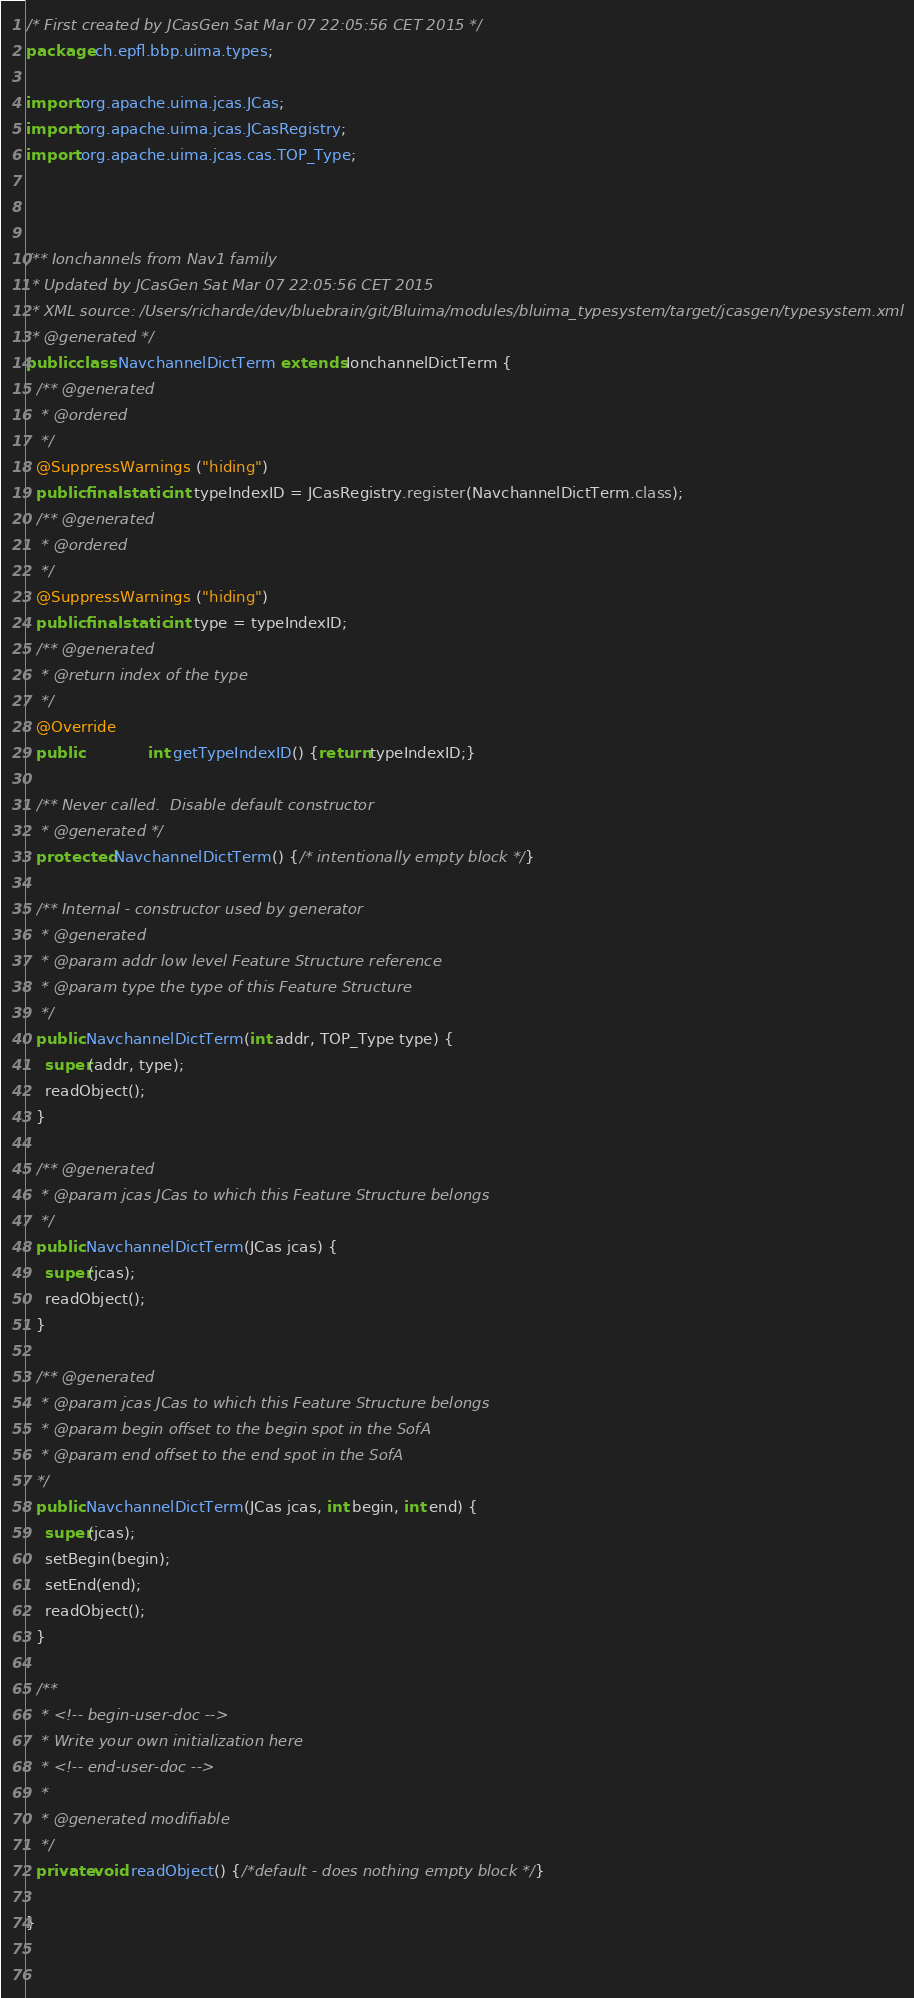<code> <loc_0><loc_0><loc_500><loc_500><_Java_>

/* First created by JCasGen Sat Mar 07 22:05:56 CET 2015 */
package ch.epfl.bbp.uima.types;

import org.apache.uima.jcas.JCas; 
import org.apache.uima.jcas.JCasRegistry;
import org.apache.uima.jcas.cas.TOP_Type;



/** Ionchannels from Nav1 family
 * Updated by JCasGen Sat Mar 07 22:05:56 CET 2015
 * XML source: /Users/richarde/dev/bluebrain/git/Bluima/modules/bluima_typesystem/target/jcasgen/typesystem.xml
 * @generated */
public class NavchannelDictTerm extends IonchannelDictTerm {
  /** @generated
   * @ordered 
   */
  @SuppressWarnings ("hiding")
  public final static int typeIndexID = JCasRegistry.register(NavchannelDictTerm.class);
  /** @generated
   * @ordered 
   */
  @SuppressWarnings ("hiding")
  public final static int type = typeIndexID;
  /** @generated
   * @return index of the type  
   */
  @Override
  public              int getTypeIndexID() {return typeIndexID;}
 
  /** Never called.  Disable default constructor
   * @generated */
  protected NavchannelDictTerm() {/* intentionally empty block */}
    
  /** Internal - constructor used by generator 
   * @generated
   * @param addr low level Feature Structure reference
   * @param type the type of this Feature Structure 
   */
  public NavchannelDictTerm(int addr, TOP_Type type) {
    super(addr, type);
    readObject();
  }
  
  /** @generated
   * @param jcas JCas to which this Feature Structure belongs 
   */
  public NavchannelDictTerm(JCas jcas) {
    super(jcas);
    readObject();   
  } 

  /** @generated
   * @param jcas JCas to which this Feature Structure belongs
   * @param begin offset to the begin spot in the SofA
   * @param end offset to the end spot in the SofA 
  */  
  public NavchannelDictTerm(JCas jcas, int begin, int end) {
    super(jcas);
    setBegin(begin);
    setEnd(end);
    readObject();
  }   

  /** 
   * <!-- begin-user-doc -->
   * Write your own initialization here
   * <!-- end-user-doc -->
   *
   * @generated modifiable 
   */
  private void readObject() {/*default - does nothing empty block */}
     
}

    </code> 